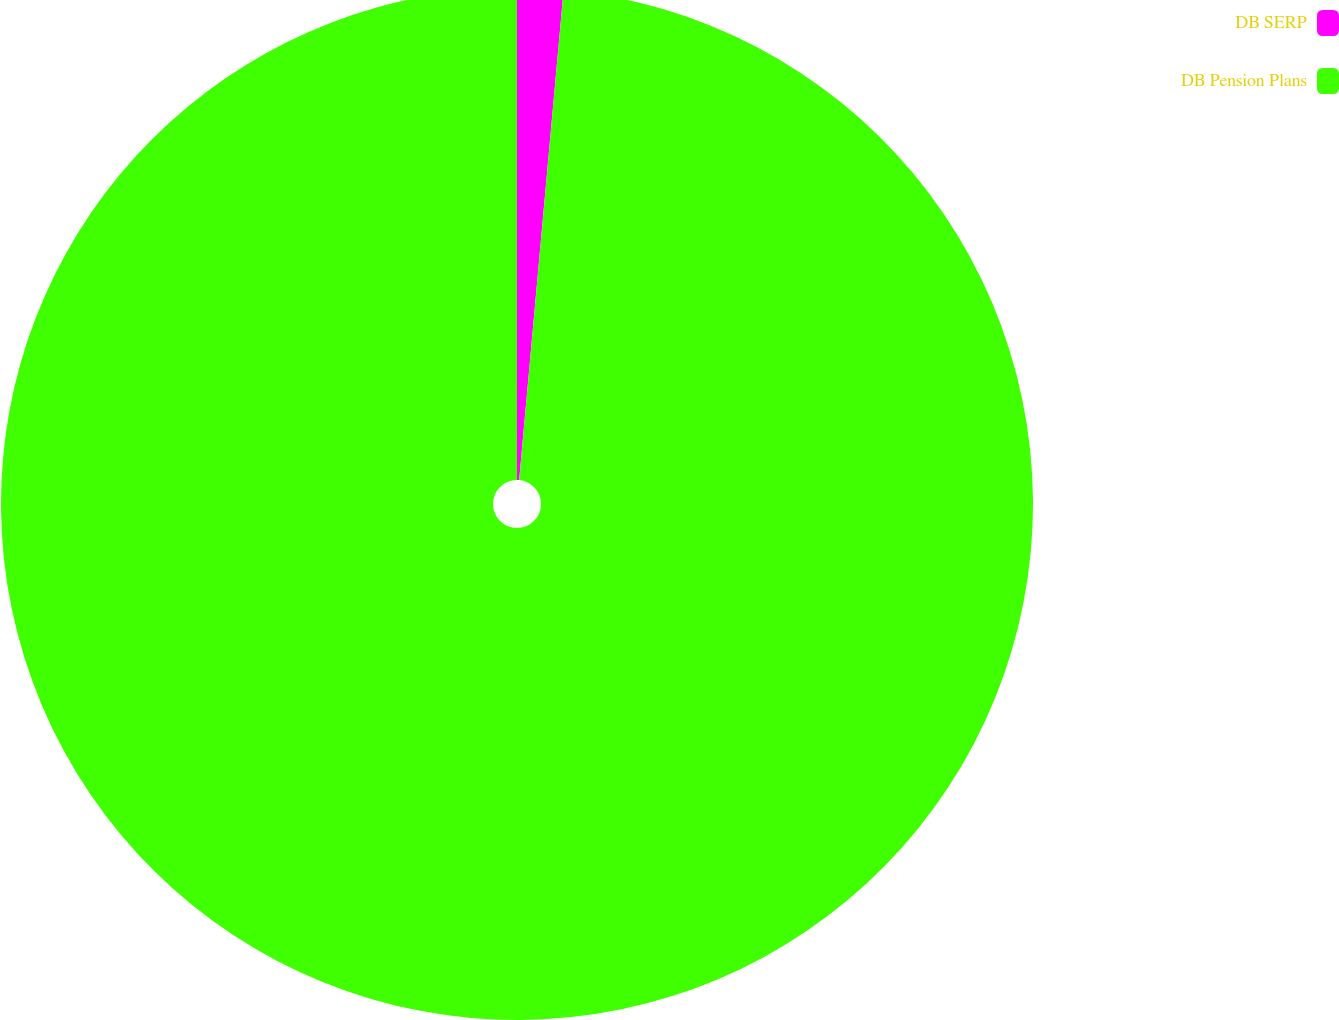Convert chart to OTSL. <chart><loc_0><loc_0><loc_500><loc_500><pie_chart><fcel>DB SERP<fcel>DB Pension Plans<nl><fcel>1.44%<fcel>98.56%<nl></chart> 